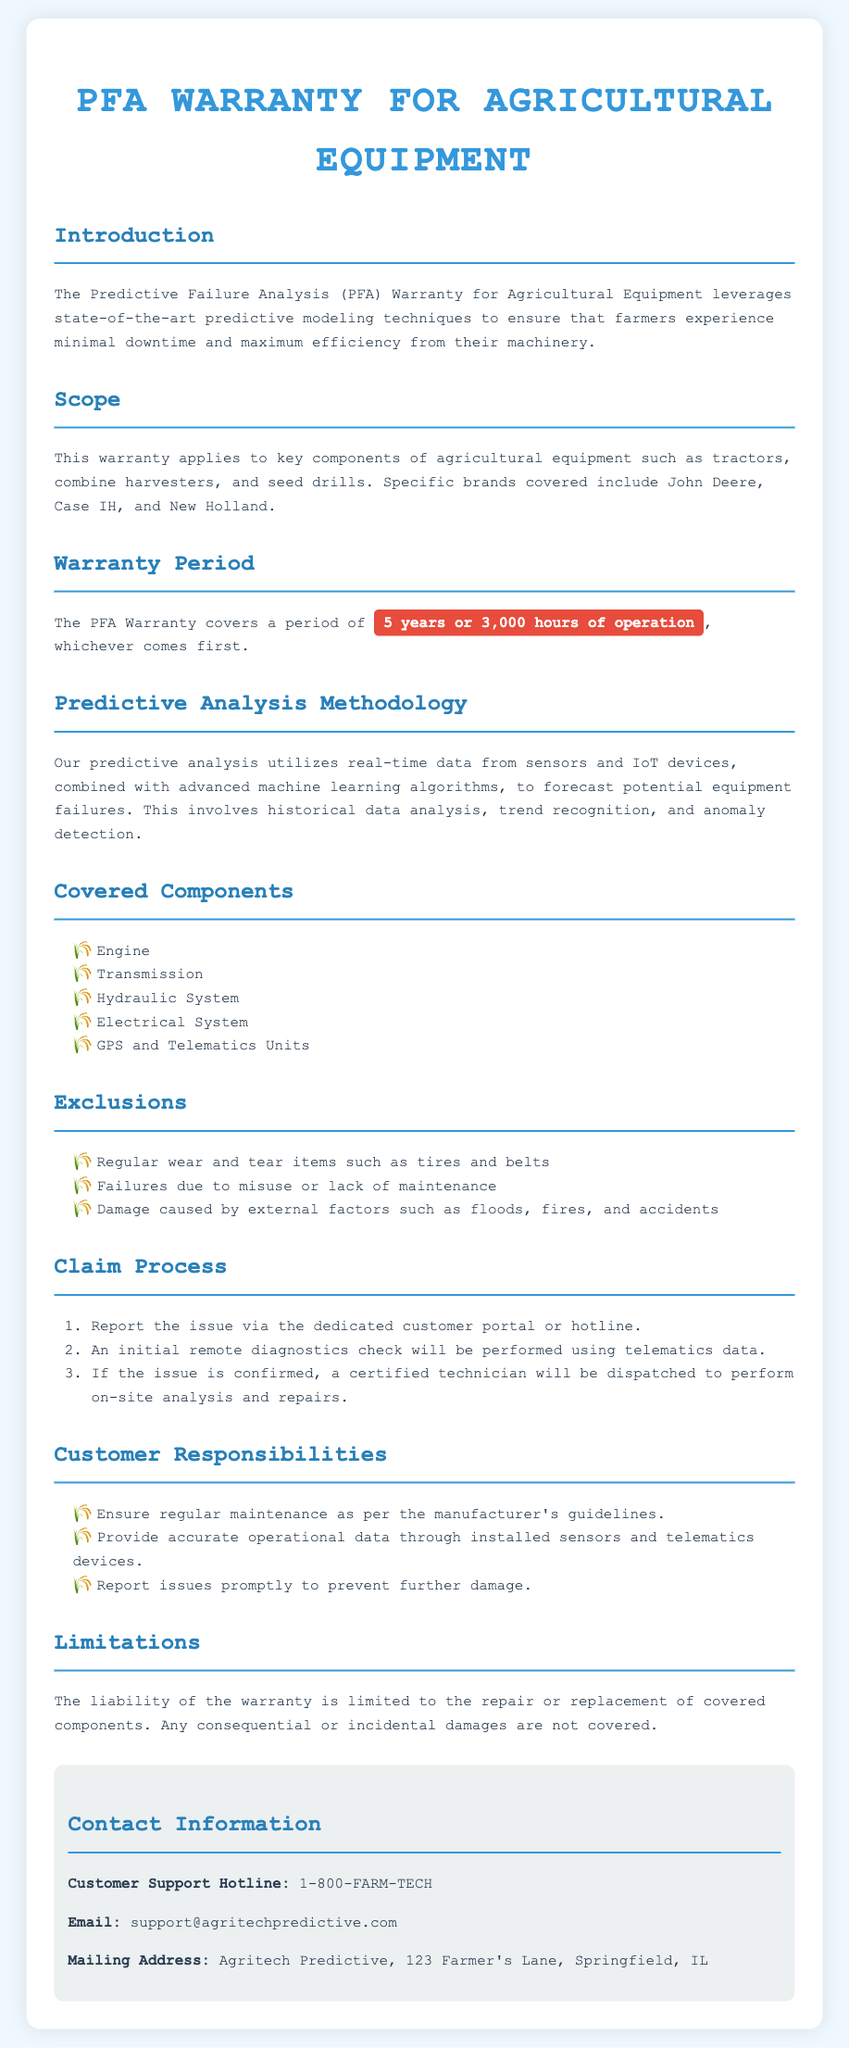What is the warranty period? The warranty period covers a duration of 5 years or 3,000 hours of operation, whichever comes first.
Answer: 5 years or 3,000 hours Which components are covered under the warranty? The document lists several components including Engine, Transmission, Hydraulic System, Electrical System, and GPS and Telematics Units.
Answer: Engine, Transmission, Hydraulic System, Electrical System, GPS and Telematics Units What type of analysis is utilized for predictive failure? The warranty utilizes predictive analysis that combines real-time data from sensors and IoT devices with advanced machine learning algorithms.
Answer: Predictive analysis What is excluded from the warranty coverage? The warranty does not cover regular wear and tear items, failures due to misuse, or damage caused by external factors.
Answer: Regular wear and tear items, misuse, external factors What is the first step in the claim process? The first step in the claim process is to report the issue via the dedicated customer portal or hotline.
Answer: Report the issue What is Agritech Predictive's customer support hotline? The document provides a specific customer support hotline number for assistance.
Answer: 1-800-FARM-TECH What should customers ensure according to their responsibilities? Customers are responsible for ensuring regular maintenance as per the manufacturer's guidelines.
Answer: Regular maintenance What type of damages are not covered by the warranty? The liability of the warranty excludes any consequential or incidental damages.
Answer: Consequential or incidental damages 